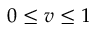<formula> <loc_0><loc_0><loc_500><loc_500>0 \leq v \leq 1</formula> 